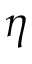Convert formula to latex. <formula><loc_0><loc_0><loc_500><loc_500>\eta</formula> 